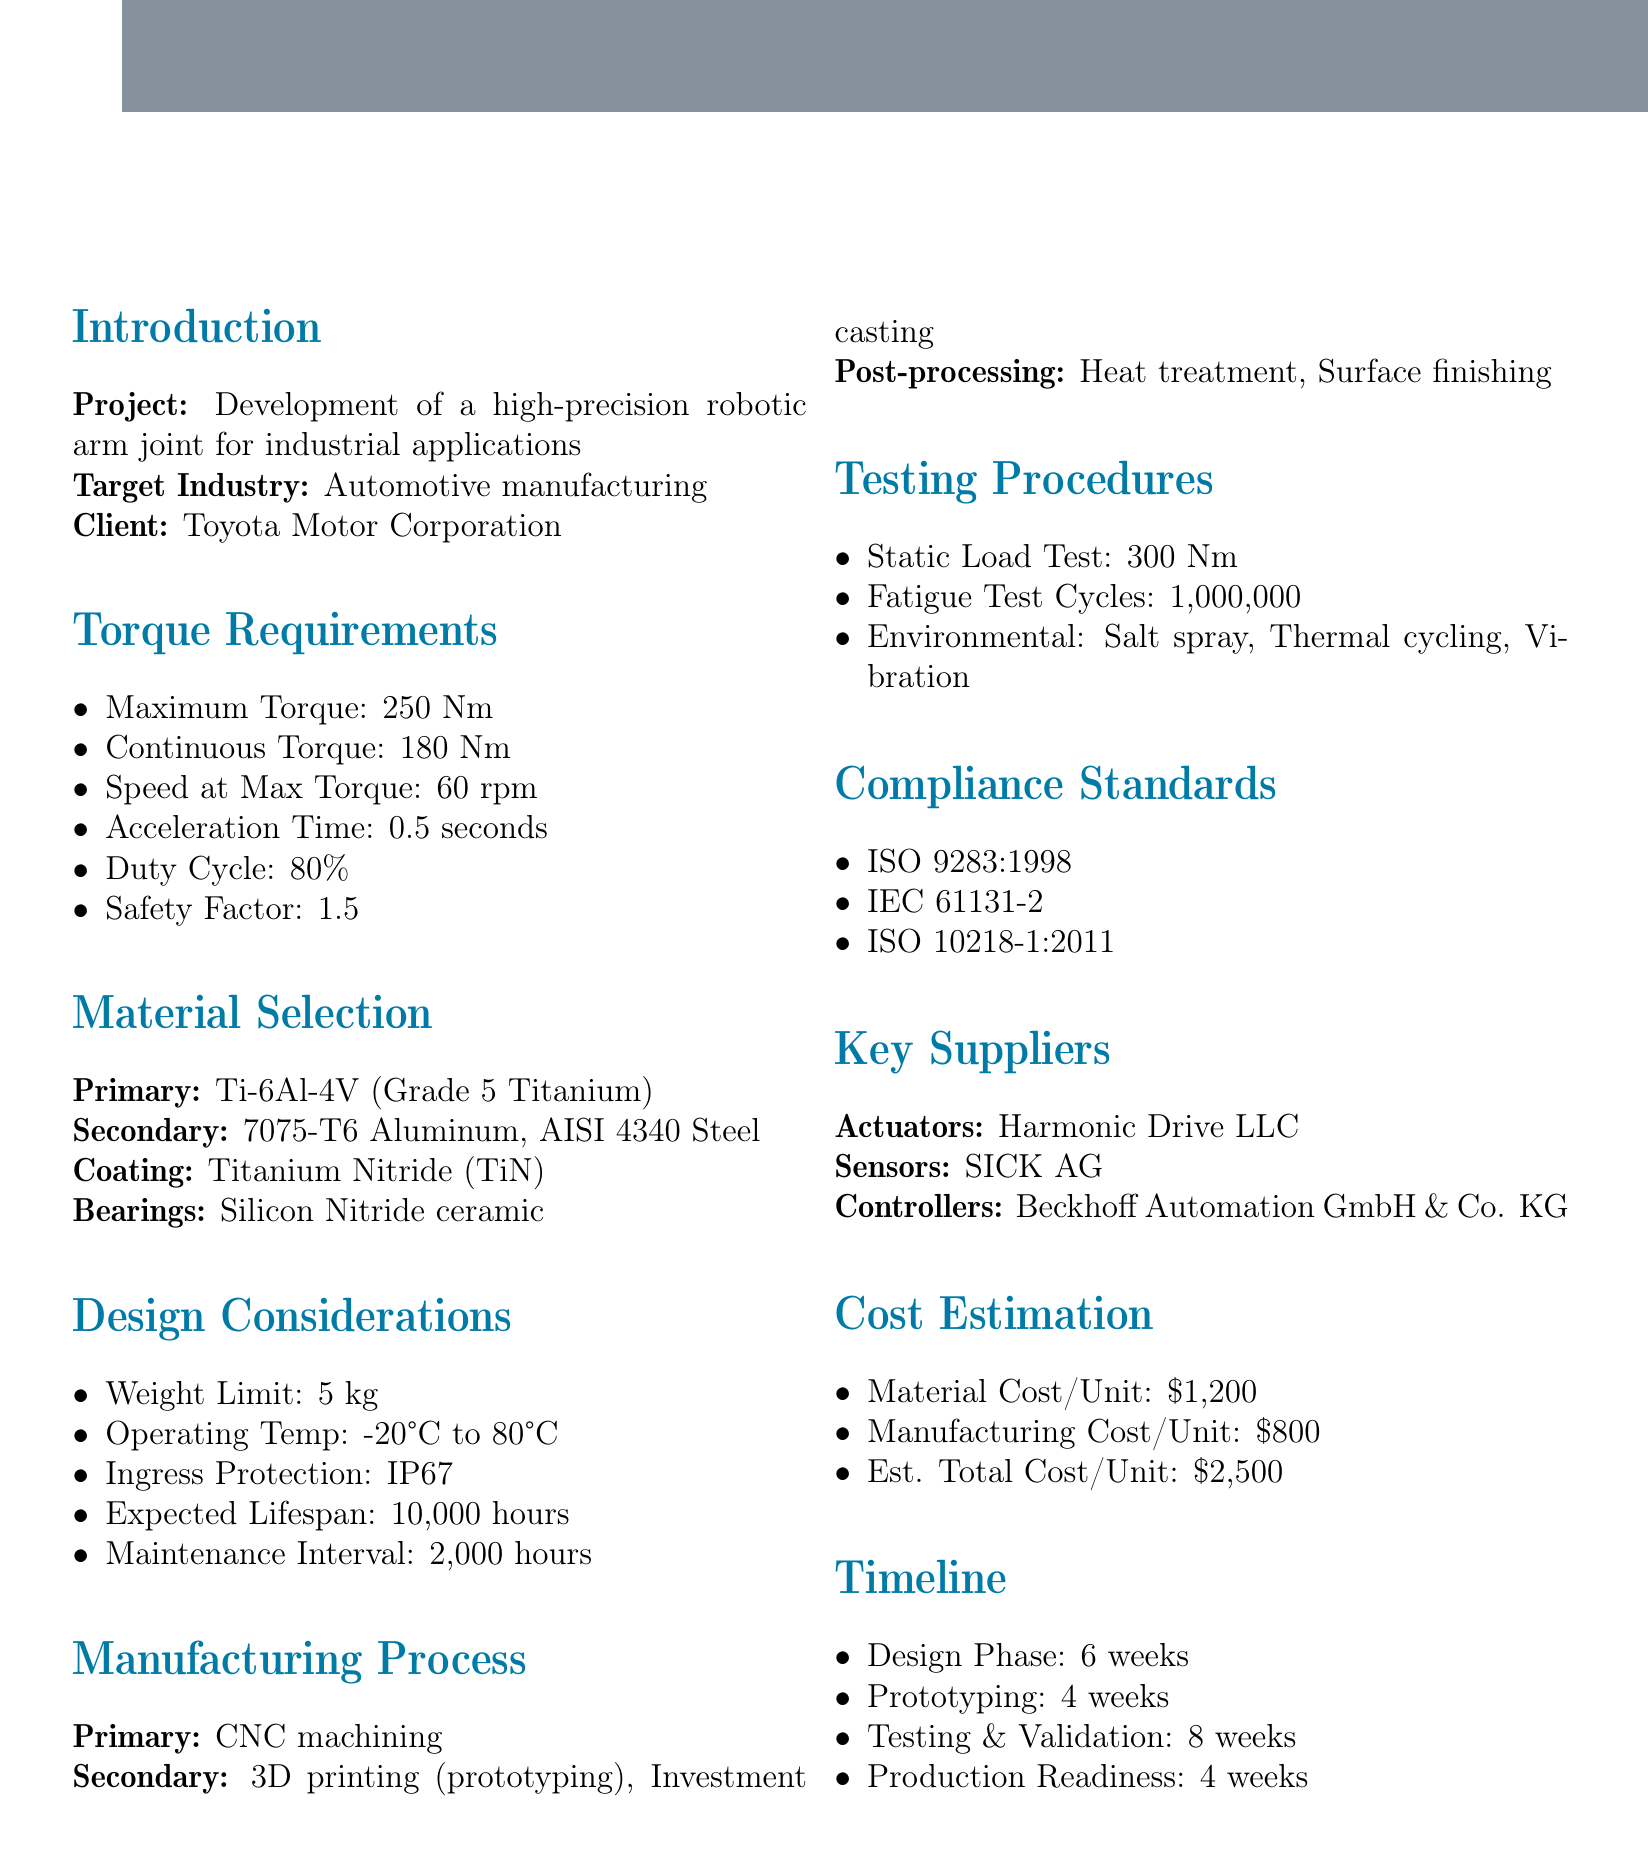what is the maximum torque specified for the robotic arm joint? The maximum torque is listed under the torque requirements as 250 Nm.
Answer: 250 Nm what is the primary material chosen for the robotic arm joint? The primary material for the joint is specified as Ti-6Al-4V (Grade 5 Titanium).
Answer: Ti-6Al-4V (Grade 5 Titanium) what is the estimated total cost per unit for the robotic arm joint? The estimated total cost per unit is found in the cost estimation section as $2500.
Answer: $2500 how many weeks are allocated for the design phase? The timeline section specifies that the design phase will take 6 weeks.
Answer: 6 weeks what is the required safety factor mentioned for the joint? The safety factor is provided in the torque requirements section as 1.5.
Answer: 1.5 what is the expected lifespan of the robotic arm joint? The expected lifespan is detailed in the design considerations as 10,000 hours.
Answer: 10,000 hours what testing procedure ensures the arm joint can handle excess loads? The testing procedure for excess loads is identified as the static load test, which is specified at 300 Nm.
Answer: static load test which coating material is selected for the robotic arm joint? The selected coating material is listed as Titanium Nitride (TiN) in the material selection section.
Answer: Titanium Nitride (TiN) what is the temperature range within which the robotic arm joint will operate? The operating temperature range is noted in design considerations as -20°C to 80°C.
Answer: -20°C to 80°C 